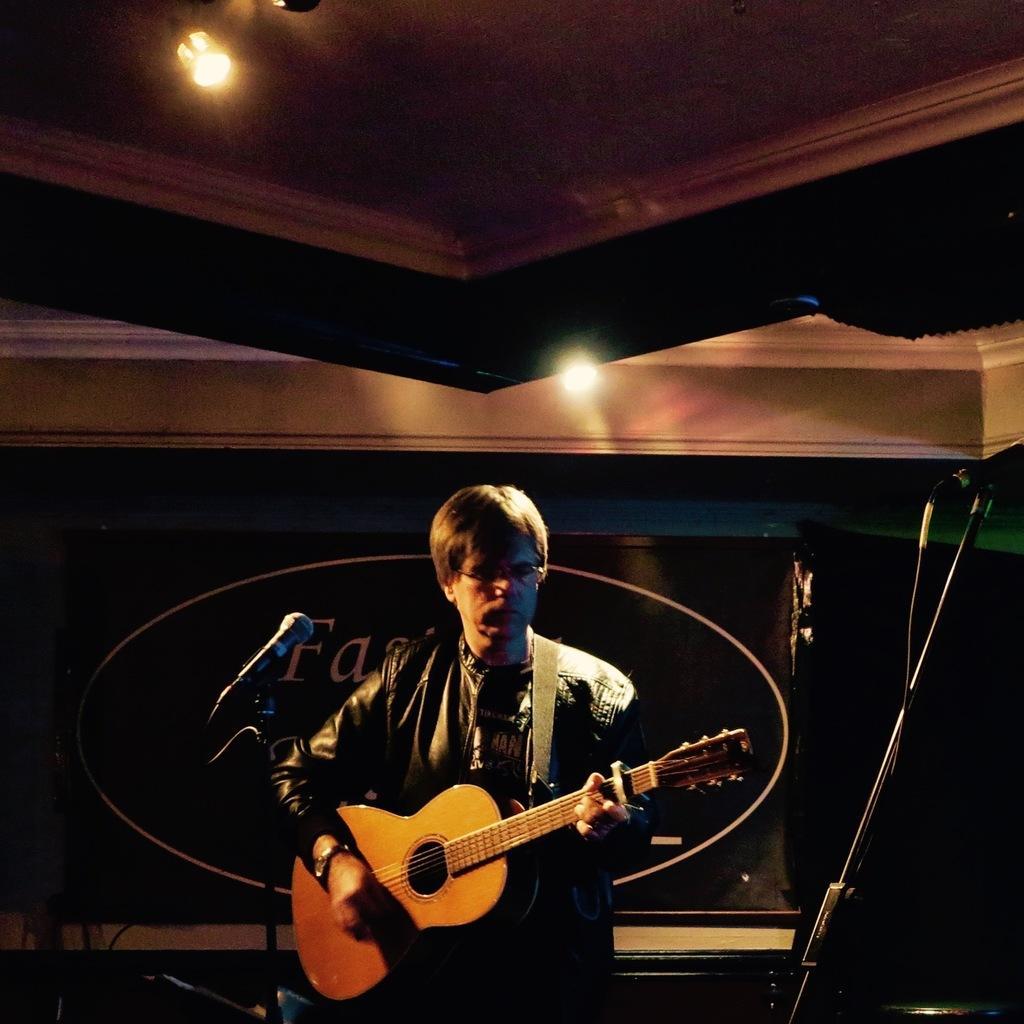In one or two sentences, can you explain what this image depicts? In this picture there is a person who is at the center of the image, he is standing and holding the guitar in his hands there is a mic at the left side of the person, there are two lights above the stage and it seems to be a stage platform. 